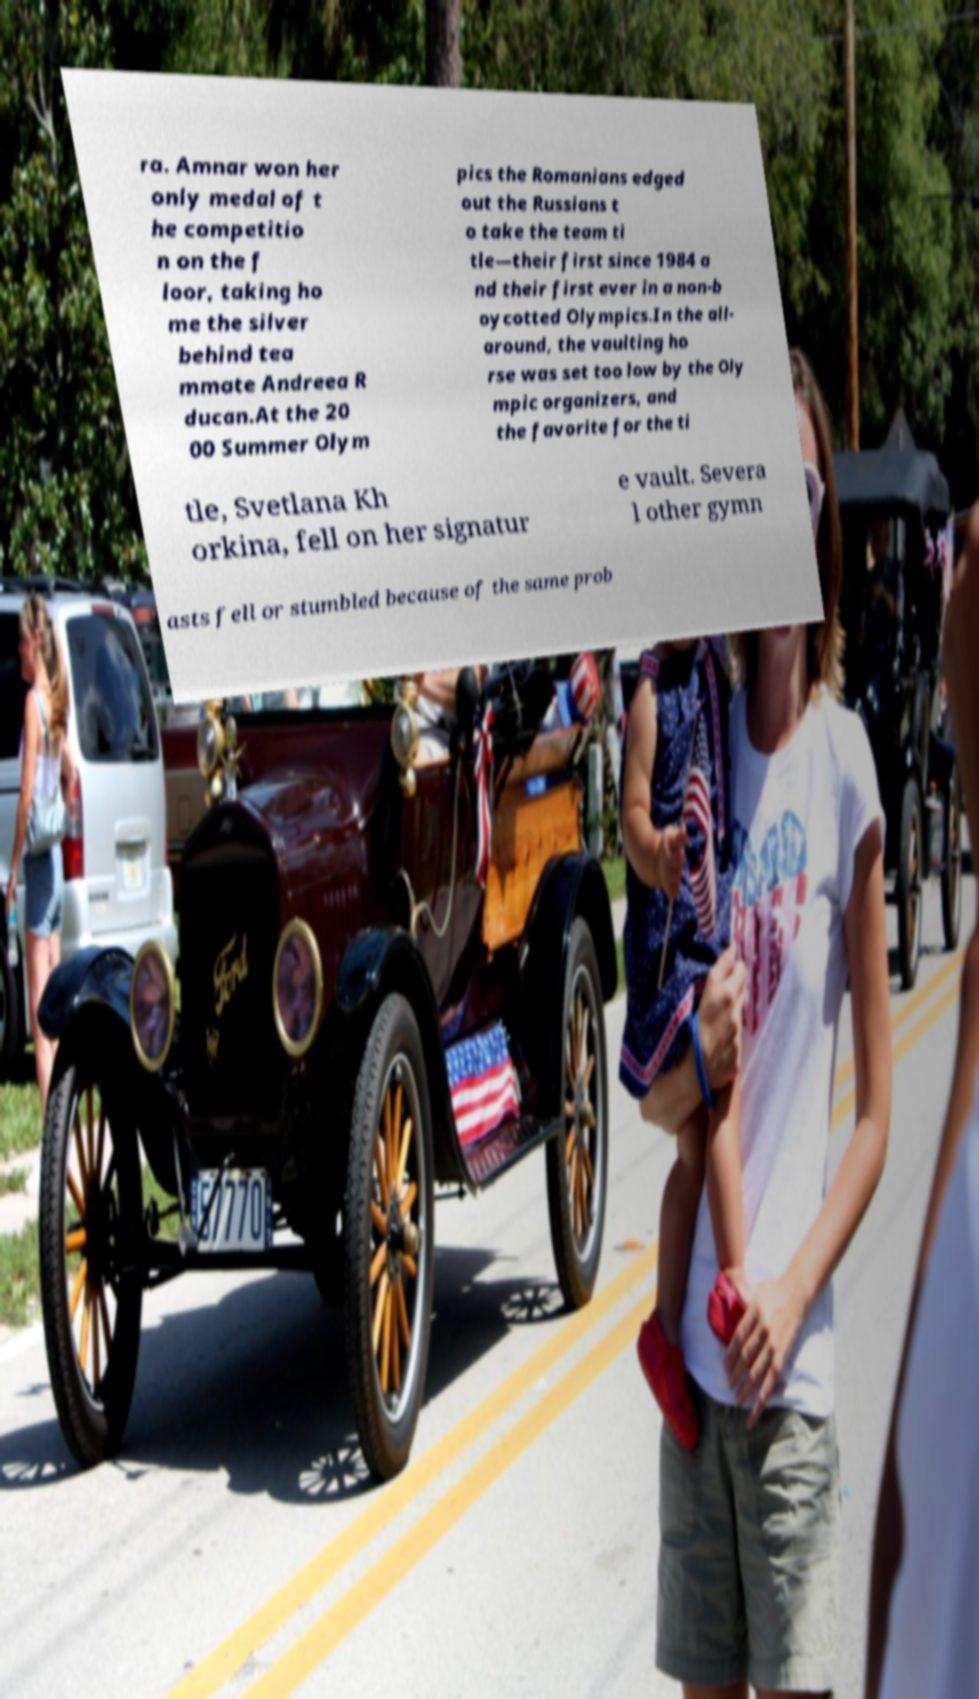For documentation purposes, I need the text within this image transcribed. Could you provide that? ra. Amnar won her only medal of t he competitio n on the f loor, taking ho me the silver behind tea mmate Andreea R ducan.At the 20 00 Summer Olym pics the Romanians edged out the Russians t o take the team ti tle—their first since 1984 a nd their first ever in a non-b oycotted Olympics.In the all- around, the vaulting ho rse was set too low by the Oly mpic organizers, and the favorite for the ti tle, Svetlana Kh orkina, fell on her signatur e vault. Severa l other gymn asts fell or stumbled because of the same prob 